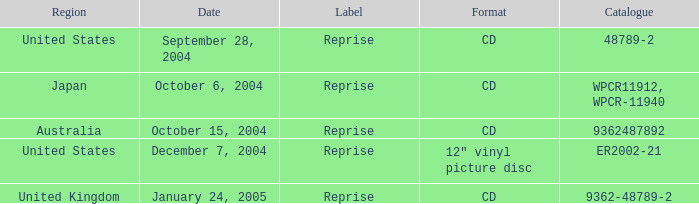Name the region for december 7, 2004 United States. 